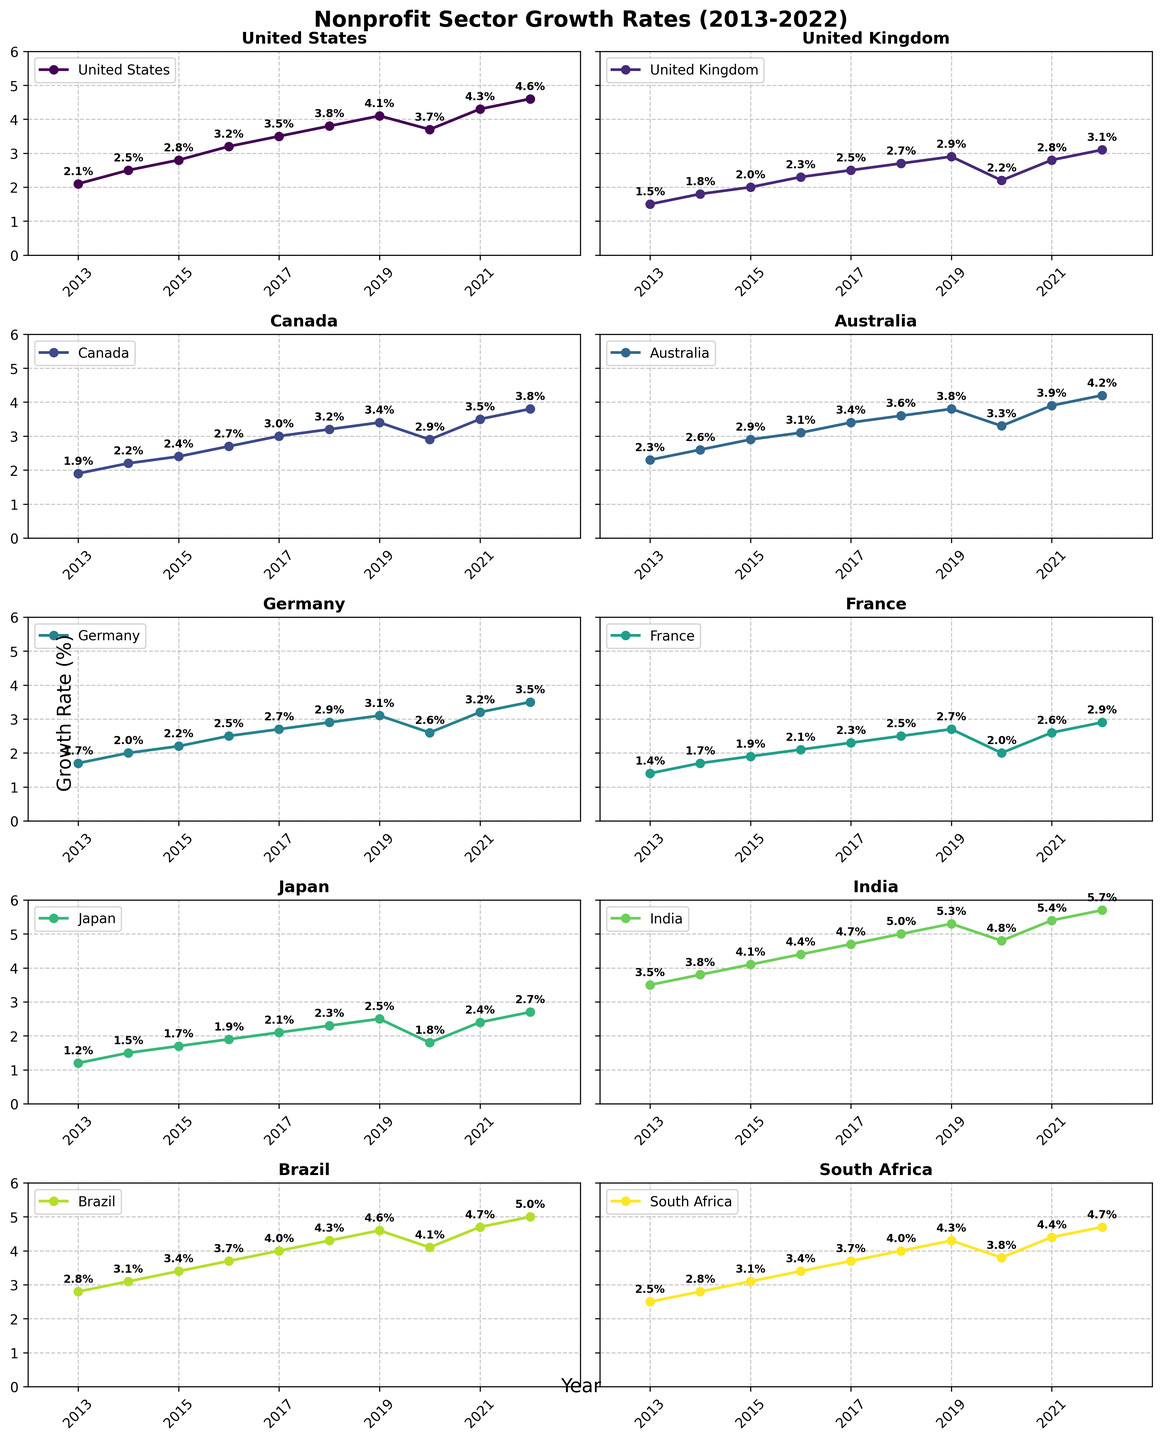What is the overall highest growth rate shown in the figure? The highest growth rate is shown in the India subplot with a value of 5.7% in 2022. By visually inspecting all subplots, 5.7% is the maximum value.
Answer: 5.7% Which country had a higher growth rate in 2015, the United Kingdom or Canada? In the United Kingdom subplot, the growth rate for 2015 is 2.0%. In the Canada subplot, the growth rate for 2015 is 2.4%.
Answer: Canada What was the average growth rate of Brazil from 2019 to 2022? Brazil's growth rates from 2019 to 2022 are 4.6%, 4.1%, 4.7%, and 5.0%. The average is calculated as (4.6 + 4.1 + 4.7 + 5.0) / 4 = 18.4 / 4 = 4.6%.
Answer: 4.6% Between which years did the United States experience the largest increase in growth rate? By examining the United States subplot, the largest increase in growth rate occurs between 2019 and 2020, where the growth rate declined from 4.1% to 3.7%.
Answer: 2018-2019 Which country had the smallest growth rate in 2017? In 2017, Japan had the smallest growth rate of 2.1%, as seen in the subplot for Japan.
Answer: Japan Compare the growth rates of South Africa and Australia in 2020. Which country had a higher growth rate and what was the difference? South Africa’s growth rate in 2020 is 3.8% and Australia’s is 3.3%. The difference is 3.8% - 3.3% = 0.5%. Therefore, South Africa had a higher growth rate by 0.5%.
Answer: South Africa by 0.5% From 2013 to 2022, which country showed the most consistent growth rate pattern? The subplot for Australia shows a relatively consistent upward trend in growth rate with fewer fluctuations compared to other countries. This can be observed from the steadily increasing values each year.
Answer: Australia How did the growth rate in France change from 2019 to 2020? The growth rate in France decreased from 2.7% in 2019 to 2.0% in 2020, a drop of 0.7%.
Answer: Decreased by 0.7% Which two countries had the closest growth rates in 2021? In 2021, Canada and Australia had very close growth rates with values of 3.5% and 3.9% respectively. The difference is only 0.4%.
Answer: Canada and Australia What is the overall trend of nonprofit sector growth in Germany from 2013 to 2022? The subplot for Germany shows a consistent upward trend in growth rate from 1.7% in 2013 to 3.5% in 2022, indicating overall growth over the decade.
Answer: Upward trend 